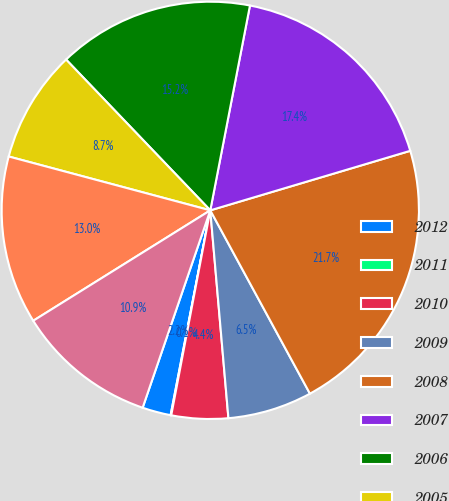<chart> <loc_0><loc_0><loc_500><loc_500><pie_chart><fcel>2012<fcel>2011<fcel>2010<fcel>2009<fcel>2008<fcel>2007<fcel>2006<fcel>2005<fcel>2004<fcel>2003<nl><fcel>2.21%<fcel>0.05%<fcel>4.38%<fcel>6.54%<fcel>21.68%<fcel>17.35%<fcel>15.19%<fcel>8.7%<fcel>13.03%<fcel>10.87%<nl></chart> 